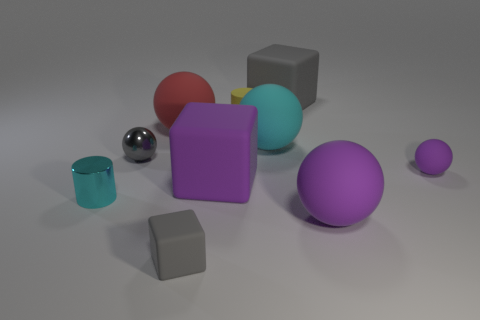How many other tiny gray balls are the same material as the gray sphere?
Offer a very short reply. 0. Are there fewer tiny rubber things than purple matte cylinders?
Give a very brief answer. No. What is the size of the purple rubber thing that is the same shape as the tiny gray matte thing?
Keep it short and to the point. Large. Do the cylinder that is in front of the metal sphere and the purple block have the same material?
Ensure brevity in your answer.  No. Does the small gray metallic object have the same shape as the red matte thing?
Your answer should be very brief. Yes. How many things are gray rubber things behind the tiny cyan thing or tiny purple shiny cylinders?
Your response must be concise. 1. What size is the cyan thing that is the same material as the big red thing?
Your answer should be compact. Large. How many tiny cubes are the same color as the rubber cylinder?
Your answer should be compact. 0. What number of big objects are either gray matte things or brown rubber balls?
Keep it short and to the point. 1. What size is the matte ball that is the same color as the shiny cylinder?
Your answer should be compact. Large. 